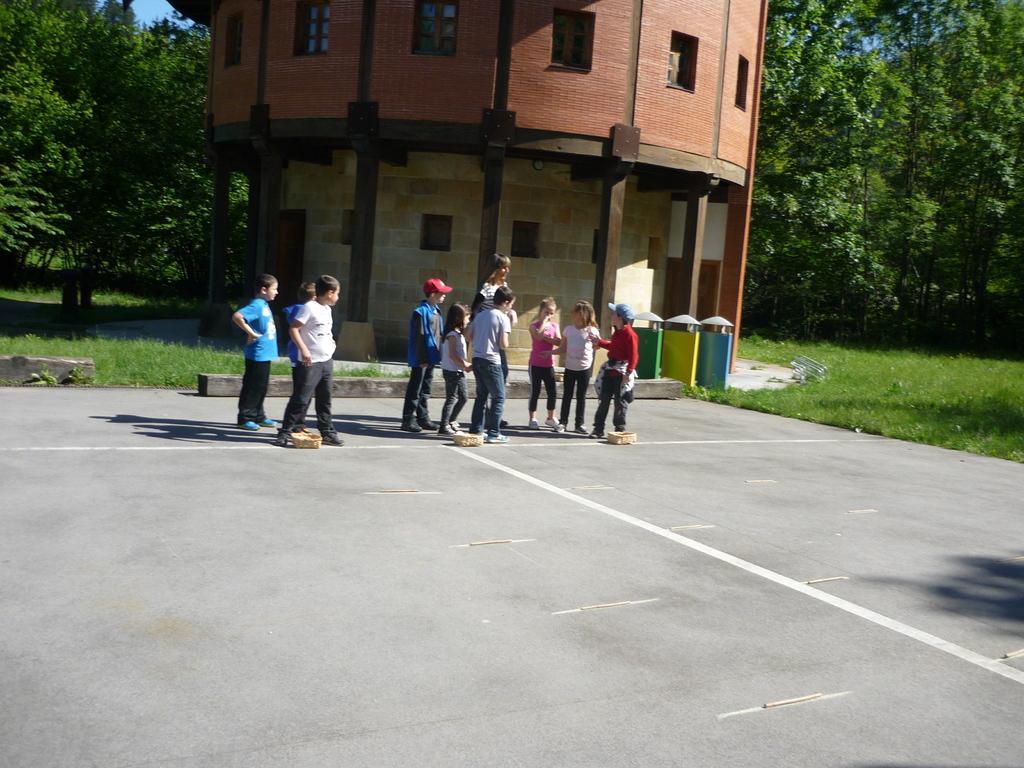In one or two sentences, can you explain what this image depicts? In this image I can see few people with different color dresses. I can see two people are wearing the caps. In the background I can see the building with windows and the dustbins. In the background I can see many trees and the blue sky. 